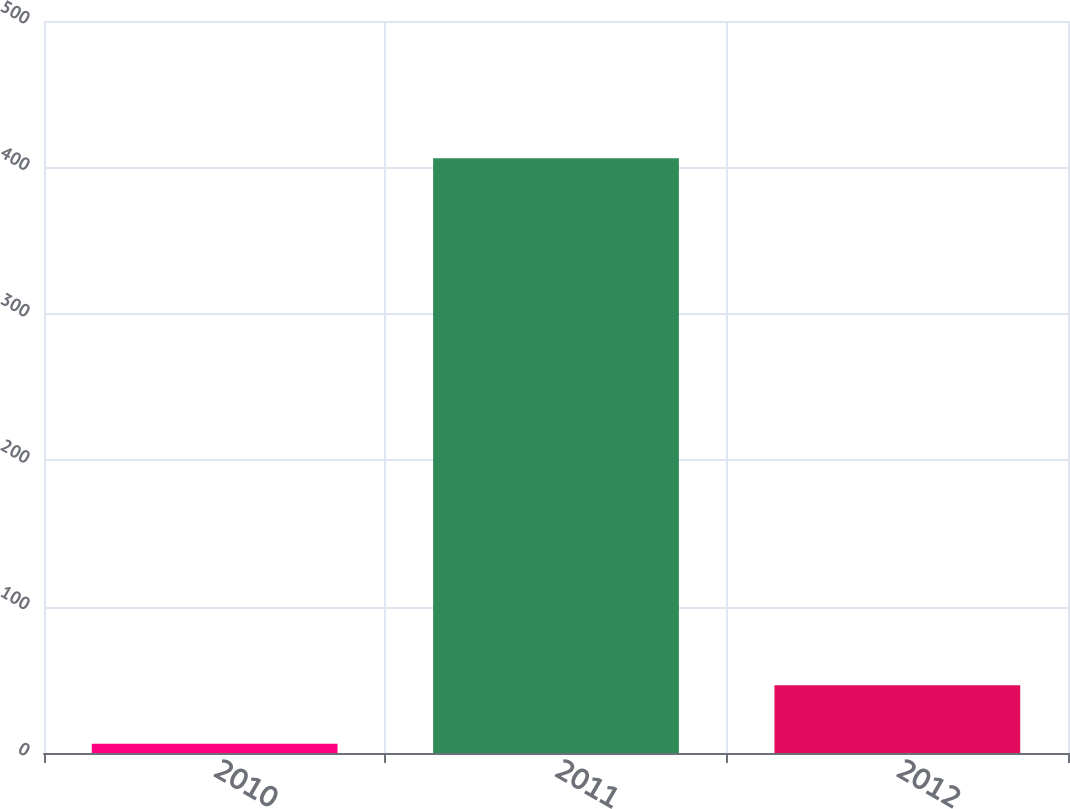Convert chart. <chart><loc_0><loc_0><loc_500><loc_500><bar_chart><fcel>2010<fcel>2011<fcel>2012<nl><fcel>6.3<fcel>406.3<fcel>46.3<nl></chart> 